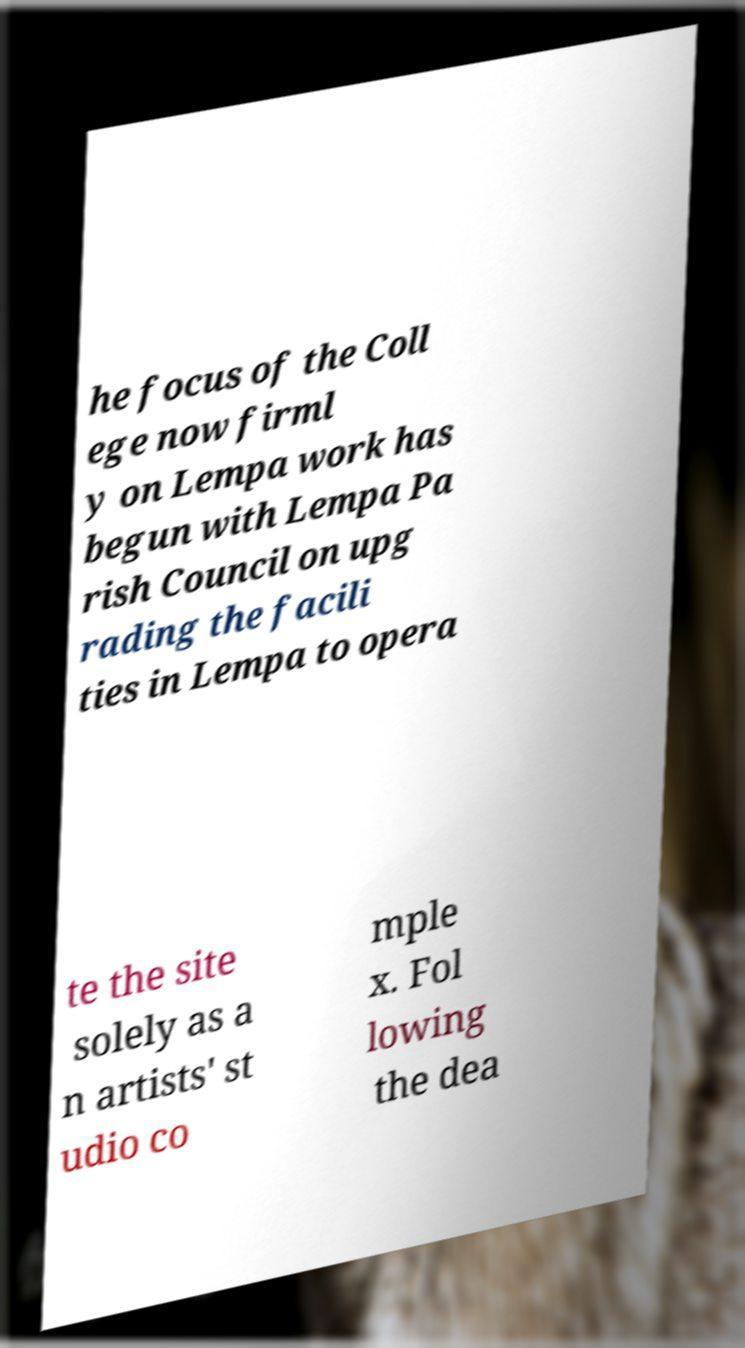Can you accurately transcribe the text from the provided image for me? he focus of the Coll ege now firml y on Lempa work has begun with Lempa Pa rish Council on upg rading the facili ties in Lempa to opera te the site solely as a n artists' st udio co mple x. Fol lowing the dea 